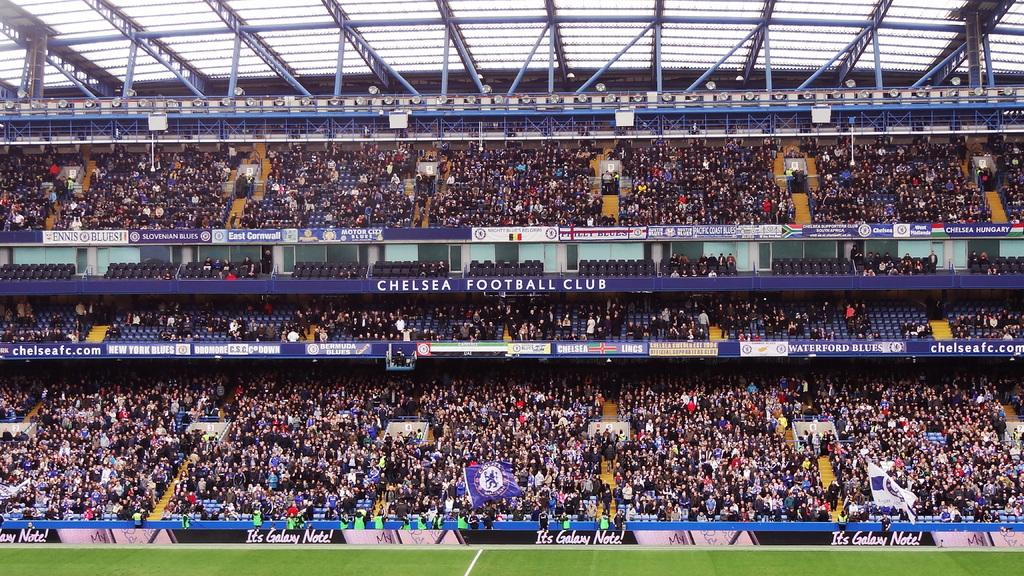<image>
Summarize the visual content of the image. The stadium is full at the Chelsea Football Blub. 